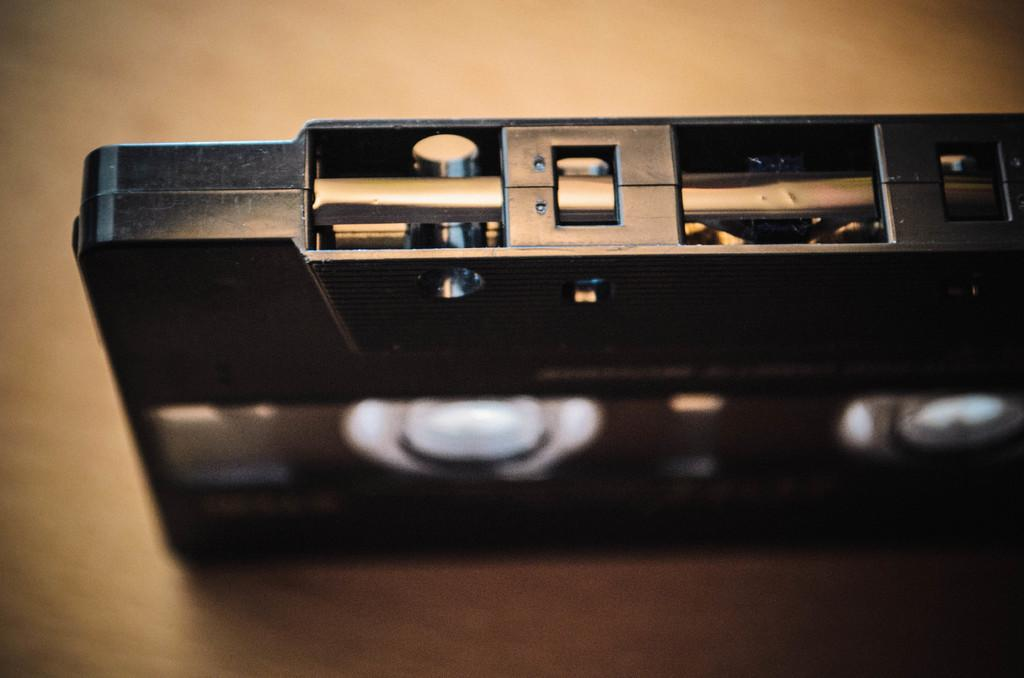What is the color of the cassette in the image? The cassette in the image is black. Can you describe any other features of the cassette? The provided facts do not mention any other features of the cassette. What type of copper cork is attached to the bike in the image? There is no copper cork or bike present in the image; it only features a black color cassette. 